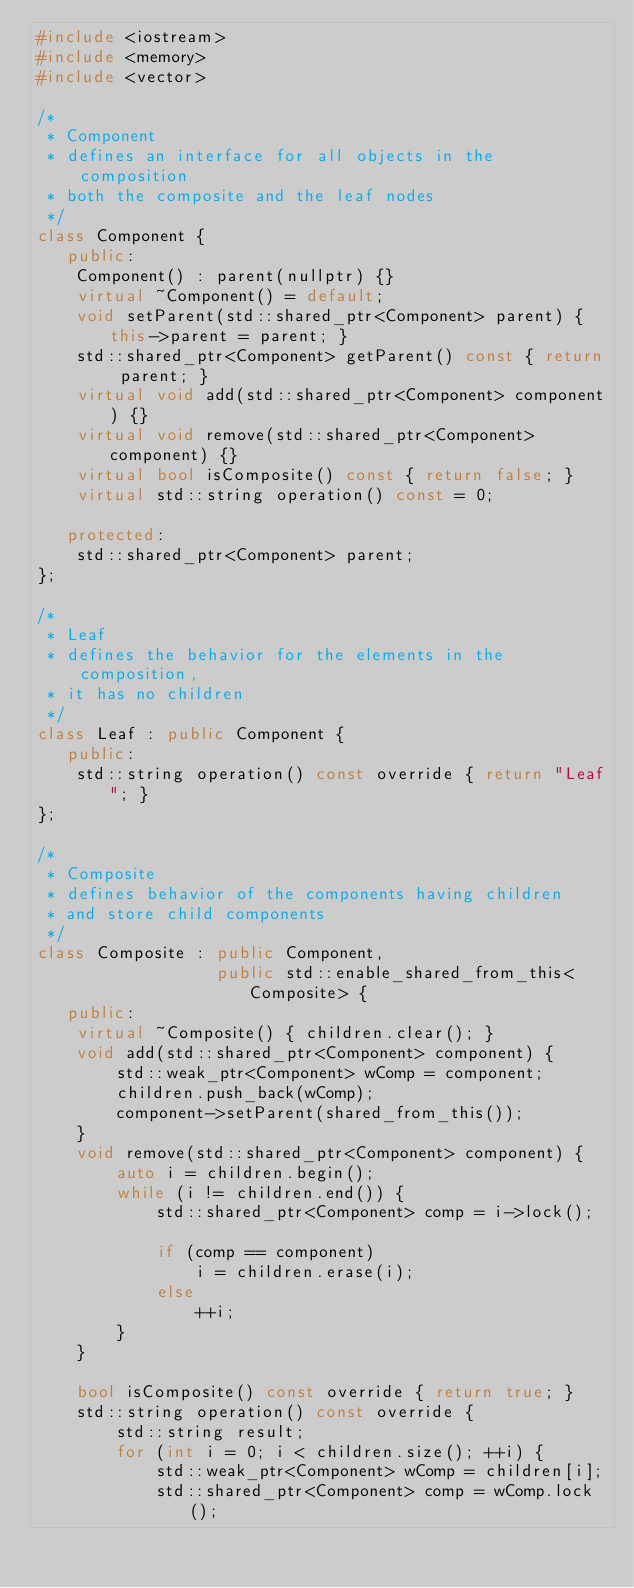<code> <loc_0><loc_0><loc_500><loc_500><_C++_>#include <iostream>
#include <memory>
#include <vector>

/*
 * Component
 * defines an interface for all objects in the composition
 * both the composite and the leaf nodes
 */
class Component {
   public:
    Component() : parent(nullptr) {}
    virtual ~Component() = default;
    void setParent(std::shared_ptr<Component> parent) { this->parent = parent; }
    std::shared_ptr<Component> getParent() const { return parent; }
    virtual void add(std::shared_ptr<Component> component) {}
    virtual void remove(std::shared_ptr<Component> component) {}
    virtual bool isComposite() const { return false; }
    virtual std::string operation() const = 0;

   protected:
    std::shared_ptr<Component> parent;
};

/*
 * Leaf
 * defines the behavior for the elements in the composition,
 * it has no children
 */
class Leaf : public Component {
   public:
    std::string operation() const override { return "Leaf"; }
};

/*
 * Composite
 * defines behavior of the components having children
 * and store child components
 */
class Composite : public Component,
                  public std::enable_shared_from_this<Composite> {
   public:
    virtual ~Composite() { children.clear(); }
    void add(std::shared_ptr<Component> component) {
        std::weak_ptr<Component> wComp = component;
        children.push_back(wComp);
        component->setParent(shared_from_this());
    }
    void remove(std::shared_ptr<Component> component) {
        auto i = children.begin();
        while (i != children.end()) {
            std::shared_ptr<Component> comp = i->lock();

            if (comp == component)
                i = children.erase(i);
            else
                ++i;
        }
    }

    bool isComposite() const override { return true; }
    std::string operation() const override {
        std::string result;
        for (int i = 0; i < children.size(); ++i) {
            std::weak_ptr<Component> wComp = children[i];
            std::shared_ptr<Component> comp = wComp.lock();
</code> 